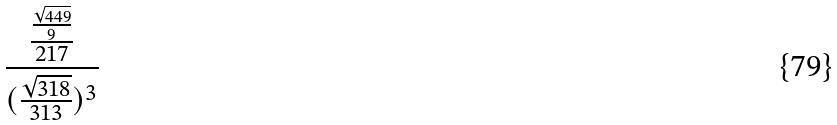<formula> <loc_0><loc_0><loc_500><loc_500>\frac { \frac { \frac { \sqrt { 4 4 9 } } { 9 } } { 2 1 7 } } { ( \frac { \sqrt { 3 1 8 } } { 3 1 3 } ) ^ { 3 } }</formula> 